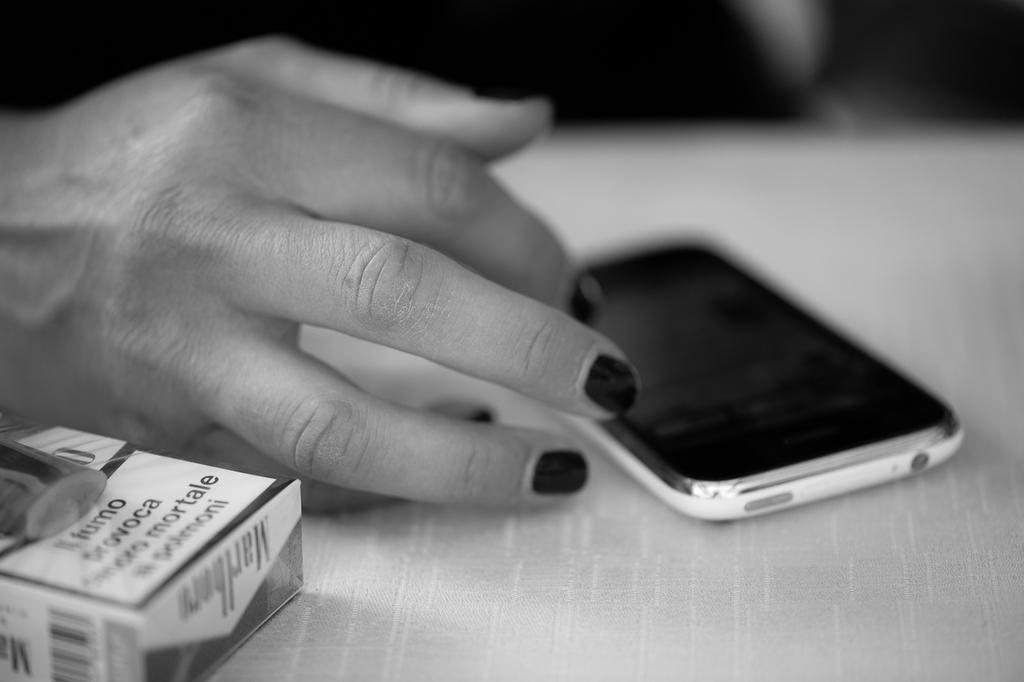<image>
Describe the image concisely. A cellphone and a packet of Marlborough cigarettes rest on a table. 